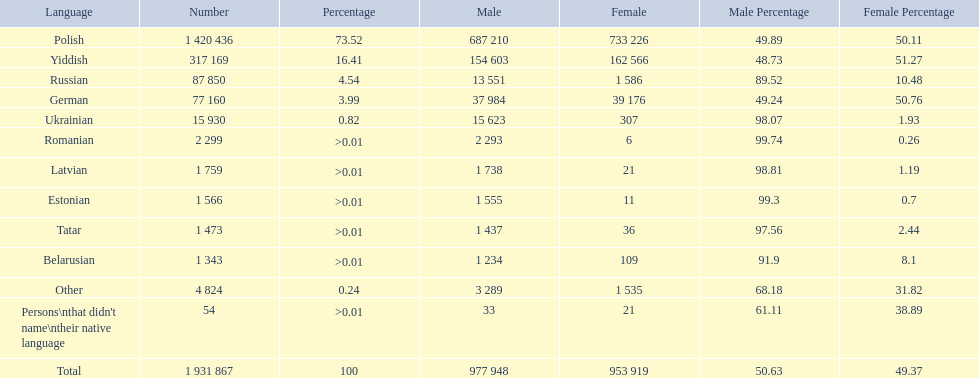What was the top language from the one's whose percentage was >0.01 Romanian. 